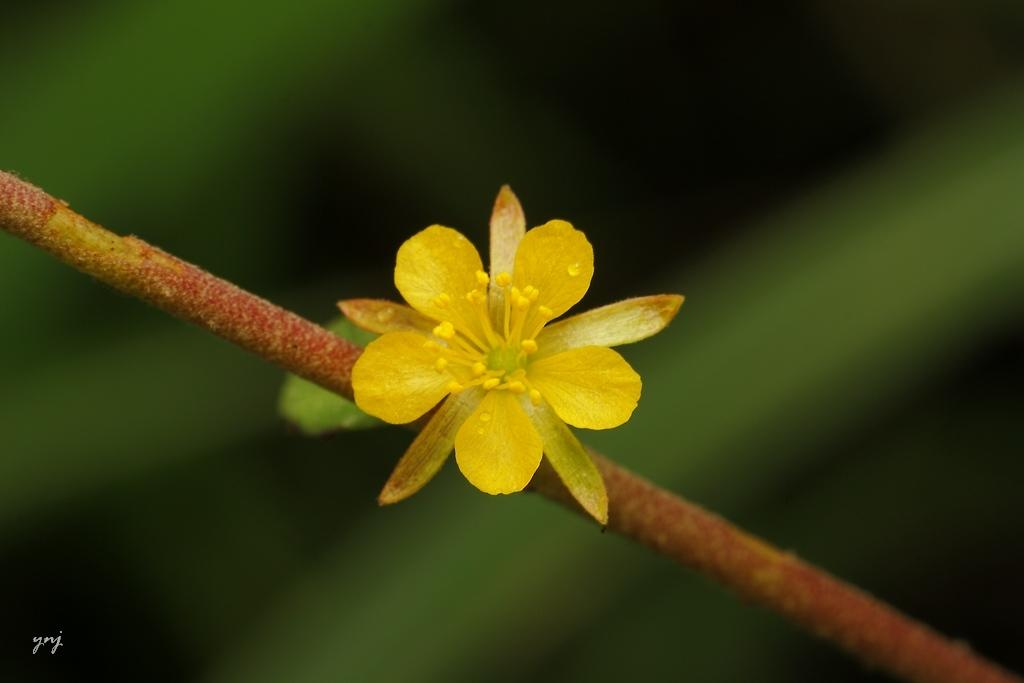What is the main subject of the image? There is a flower on a stem in the center of the image. How is the background of the image depicted? The background of the image is blurred. Is there any text present in the image? Yes, there is text at the bottom of the image. Can you tell me the opinion of the deer in the image? There is no deer present in the image, so it is not possible to determine its opinion. What sound does the bell make in the image? There is no bell present in the image, so it is not possible to determine the sound it makes. 